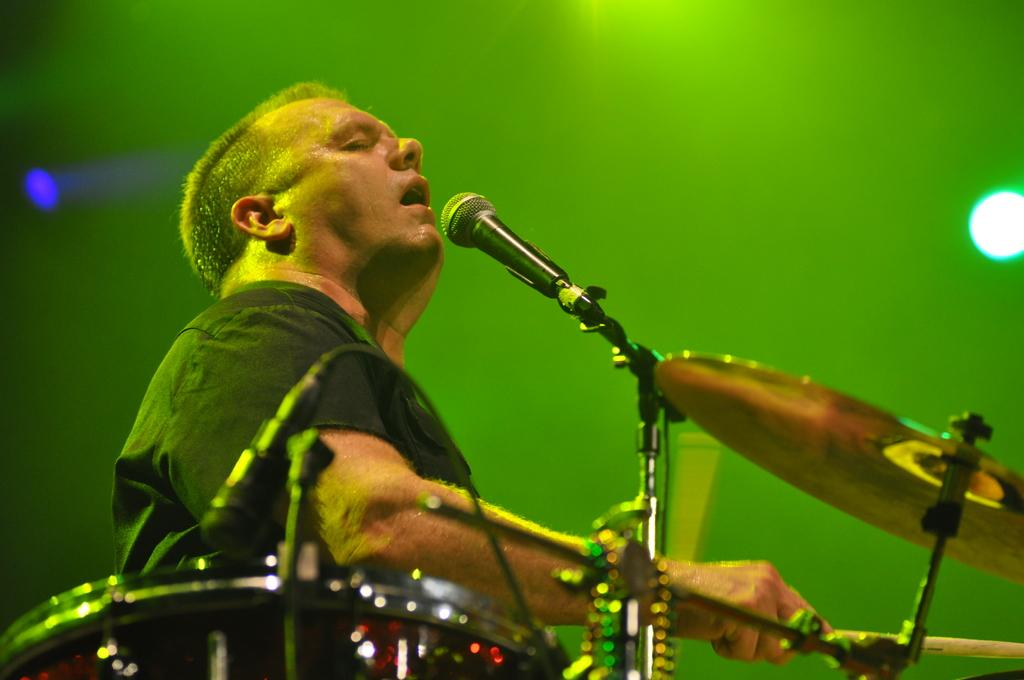What is the man in the image doing? The man is playing musical instruments and singing into a microphone. Can you describe the man's actions in more detail? The man is playing musical instruments and using a microphone to amplify his voice while singing. What is visible on the right side of the image? There is a light on the right side of the image. Can you tell me how many corks are on the floor in the image? There are no corks present in the image. What type of cave can be seen in the background of the image? There is no cave present in the image; it features a man playing musical instruments and singing into a microphone. 